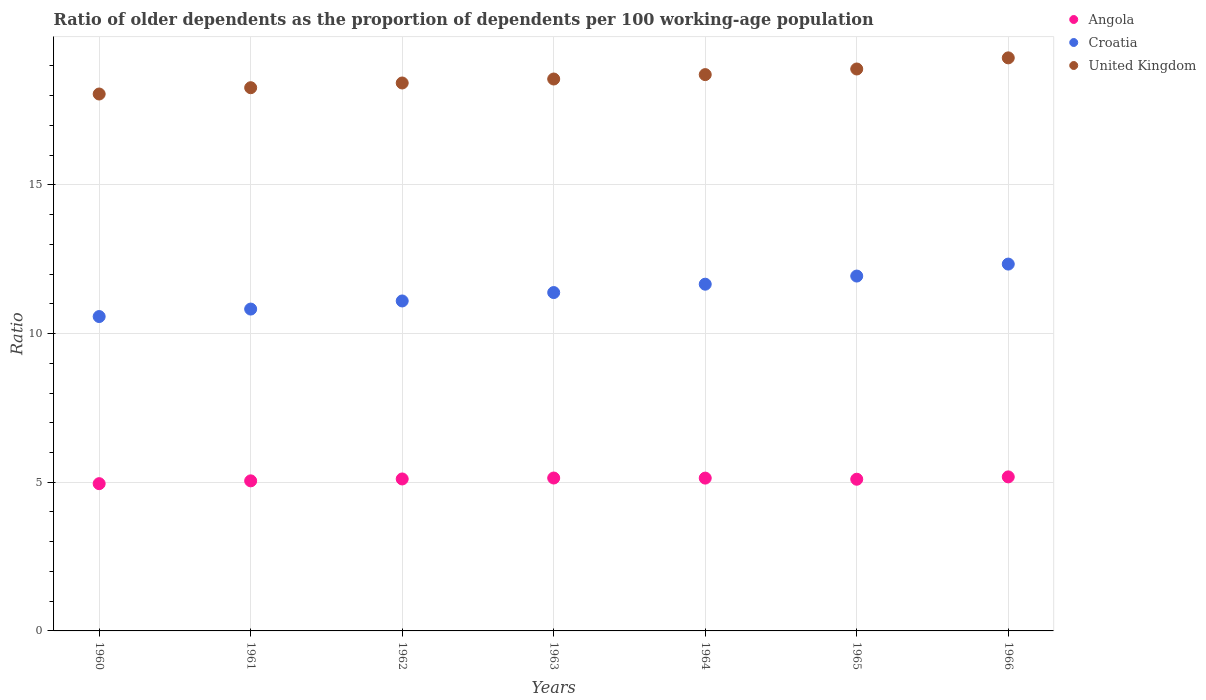How many different coloured dotlines are there?
Your answer should be compact. 3. Is the number of dotlines equal to the number of legend labels?
Provide a succinct answer. Yes. What is the age dependency ratio(old) in Angola in 1961?
Your response must be concise. 5.05. Across all years, what is the maximum age dependency ratio(old) in Angola?
Ensure brevity in your answer.  5.18. Across all years, what is the minimum age dependency ratio(old) in Croatia?
Ensure brevity in your answer.  10.57. In which year was the age dependency ratio(old) in Angola maximum?
Give a very brief answer. 1966. In which year was the age dependency ratio(old) in United Kingdom minimum?
Provide a short and direct response. 1960. What is the total age dependency ratio(old) in United Kingdom in the graph?
Ensure brevity in your answer.  130.18. What is the difference between the age dependency ratio(old) in Angola in 1960 and that in 1962?
Keep it short and to the point. -0.16. What is the difference between the age dependency ratio(old) in Croatia in 1960 and the age dependency ratio(old) in Angola in 1961?
Ensure brevity in your answer.  5.53. What is the average age dependency ratio(old) in Croatia per year?
Offer a very short reply. 11.4. In the year 1960, what is the difference between the age dependency ratio(old) in Croatia and age dependency ratio(old) in United Kingdom?
Ensure brevity in your answer.  -7.48. In how many years, is the age dependency ratio(old) in Croatia greater than 11?
Provide a short and direct response. 5. What is the ratio of the age dependency ratio(old) in United Kingdom in 1961 to that in 1963?
Your answer should be very brief. 0.98. Is the age dependency ratio(old) in Angola in 1961 less than that in 1964?
Your answer should be very brief. Yes. Is the difference between the age dependency ratio(old) in Croatia in 1962 and 1963 greater than the difference between the age dependency ratio(old) in United Kingdom in 1962 and 1963?
Offer a very short reply. No. What is the difference between the highest and the second highest age dependency ratio(old) in United Kingdom?
Keep it short and to the point. 0.37. What is the difference between the highest and the lowest age dependency ratio(old) in United Kingdom?
Make the answer very short. 1.22. In how many years, is the age dependency ratio(old) in United Kingdom greater than the average age dependency ratio(old) in United Kingdom taken over all years?
Keep it short and to the point. 3. Is the sum of the age dependency ratio(old) in Angola in 1960 and 1964 greater than the maximum age dependency ratio(old) in United Kingdom across all years?
Keep it short and to the point. No. Does the age dependency ratio(old) in Angola monotonically increase over the years?
Keep it short and to the point. No. Is the age dependency ratio(old) in Croatia strictly less than the age dependency ratio(old) in United Kingdom over the years?
Keep it short and to the point. Yes. How many dotlines are there?
Provide a short and direct response. 3. How many years are there in the graph?
Provide a succinct answer. 7. Does the graph contain any zero values?
Offer a very short reply. No. Does the graph contain grids?
Offer a very short reply. Yes. Where does the legend appear in the graph?
Your answer should be compact. Top right. What is the title of the graph?
Your answer should be compact. Ratio of older dependents as the proportion of dependents per 100 working-age population. What is the label or title of the X-axis?
Provide a short and direct response. Years. What is the label or title of the Y-axis?
Keep it short and to the point. Ratio. What is the Ratio in Angola in 1960?
Your answer should be compact. 4.95. What is the Ratio of Croatia in 1960?
Your response must be concise. 10.57. What is the Ratio in United Kingdom in 1960?
Your response must be concise. 18.05. What is the Ratio in Angola in 1961?
Your response must be concise. 5.05. What is the Ratio of Croatia in 1961?
Provide a short and direct response. 10.82. What is the Ratio of United Kingdom in 1961?
Offer a very short reply. 18.27. What is the Ratio of Angola in 1962?
Make the answer very short. 5.11. What is the Ratio of Croatia in 1962?
Provide a succinct answer. 11.1. What is the Ratio in United Kingdom in 1962?
Give a very brief answer. 18.43. What is the Ratio in Angola in 1963?
Keep it short and to the point. 5.14. What is the Ratio in Croatia in 1963?
Make the answer very short. 11.38. What is the Ratio of United Kingdom in 1963?
Offer a very short reply. 18.56. What is the Ratio of Angola in 1964?
Make the answer very short. 5.14. What is the Ratio in Croatia in 1964?
Keep it short and to the point. 11.66. What is the Ratio in United Kingdom in 1964?
Ensure brevity in your answer.  18.71. What is the Ratio in Angola in 1965?
Provide a succinct answer. 5.1. What is the Ratio in Croatia in 1965?
Ensure brevity in your answer.  11.93. What is the Ratio of United Kingdom in 1965?
Your answer should be compact. 18.9. What is the Ratio in Angola in 1966?
Your answer should be very brief. 5.18. What is the Ratio of Croatia in 1966?
Offer a terse response. 12.34. What is the Ratio of United Kingdom in 1966?
Offer a terse response. 19.27. Across all years, what is the maximum Ratio of Angola?
Offer a very short reply. 5.18. Across all years, what is the maximum Ratio in Croatia?
Offer a terse response. 12.34. Across all years, what is the maximum Ratio in United Kingdom?
Ensure brevity in your answer.  19.27. Across all years, what is the minimum Ratio of Angola?
Your answer should be compact. 4.95. Across all years, what is the minimum Ratio in Croatia?
Your answer should be compact. 10.57. Across all years, what is the minimum Ratio of United Kingdom?
Your answer should be very brief. 18.05. What is the total Ratio of Angola in the graph?
Give a very brief answer. 35.67. What is the total Ratio of Croatia in the graph?
Keep it short and to the point. 79.8. What is the total Ratio of United Kingdom in the graph?
Your answer should be very brief. 130.18. What is the difference between the Ratio of Angola in 1960 and that in 1961?
Provide a short and direct response. -0.09. What is the difference between the Ratio in Croatia in 1960 and that in 1961?
Offer a terse response. -0.25. What is the difference between the Ratio of United Kingdom in 1960 and that in 1961?
Provide a short and direct response. -0.21. What is the difference between the Ratio of Angola in 1960 and that in 1962?
Ensure brevity in your answer.  -0.16. What is the difference between the Ratio of Croatia in 1960 and that in 1962?
Your answer should be very brief. -0.52. What is the difference between the Ratio in United Kingdom in 1960 and that in 1962?
Give a very brief answer. -0.37. What is the difference between the Ratio in Angola in 1960 and that in 1963?
Your answer should be compact. -0.19. What is the difference between the Ratio of Croatia in 1960 and that in 1963?
Keep it short and to the point. -0.81. What is the difference between the Ratio of United Kingdom in 1960 and that in 1963?
Your answer should be very brief. -0.5. What is the difference between the Ratio of Angola in 1960 and that in 1964?
Offer a terse response. -0.19. What is the difference between the Ratio in Croatia in 1960 and that in 1964?
Provide a succinct answer. -1.09. What is the difference between the Ratio of United Kingdom in 1960 and that in 1964?
Provide a short and direct response. -0.65. What is the difference between the Ratio in Angola in 1960 and that in 1965?
Ensure brevity in your answer.  -0.15. What is the difference between the Ratio of Croatia in 1960 and that in 1965?
Your answer should be compact. -1.36. What is the difference between the Ratio of United Kingdom in 1960 and that in 1965?
Ensure brevity in your answer.  -0.84. What is the difference between the Ratio of Angola in 1960 and that in 1966?
Your response must be concise. -0.23. What is the difference between the Ratio of Croatia in 1960 and that in 1966?
Provide a succinct answer. -1.76. What is the difference between the Ratio in United Kingdom in 1960 and that in 1966?
Your response must be concise. -1.22. What is the difference between the Ratio of Angola in 1961 and that in 1962?
Offer a terse response. -0.06. What is the difference between the Ratio of Croatia in 1961 and that in 1962?
Make the answer very short. -0.27. What is the difference between the Ratio of United Kingdom in 1961 and that in 1962?
Give a very brief answer. -0.16. What is the difference between the Ratio in Angola in 1961 and that in 1963?
Your response must be concise. -0.1. What is the difference between the Ratio of Croatia in 1961 and that in 1963?
Provide a short and direct response. -0.56. What is the difference between the Ratio of United Kingdom in 1961 and that in 1963?
Provide a succinct answer. -0.29. What is the difference between the Ratio in Angola in 1961 and that in 1964?
Make the answer very short. -0.09. What is the difference between the Ratio in Croatia in 1961 and that in 1964?
Your response must be concise. -0.84. What is the difference between the Ratio of United Kingdom in 1961 and that in 1964?
Offer a very short reply. -0.44. What is the difference between the Ratio in Angola in 1961 and that in 1965?
Offer a very short reply. -0.05. What is the difference between the Ratio of Croatia in 1961 and that in 1965?
Offer a terse response. -1.11. What is the difference between the Ratio in United Kingdom in 1961 and that in 1965?
Keep it short and to the point. -0.63. What is the difference between the Ratio in Angola in 1961 and that in 1966?
Provide a succinct answer. -0.13. What is the difference between the Ratio in Croatia in 1961 and that in 1966?
Offer a terse response. -1.51. What is the difference between the Ratio in United Kingdom in 1961 and that in 1966?
Provide a succinct answer. -1. What is the difference between the Ratio of Angola in 1962 and that in 1963?
Provide a succinct answer. -0.03. What is the difference between the Ratio in Croatia in 1962 and that in 1963?
Keep it short and to the point. -0.28. What is the difference between the Ratio of United Kingdom in 1962 and that in 1963?
Offer a very short reply. -0.13. What is the difference between the Ratio in Angola in 1962 and that in 1964?
Offer a very short reply. -0.03. What is the difference between the Ratio in Croatia in 1962 and that in 1964?
Your response must be concise. -0.56. What is the difference between the Ratio of United Kingdom in 1962 and that in 1964?
Your answer should be compact. -0.28. What is the difference between the Ratio of Angola in 1962 and that in 1965?
Keep it short and to the point. 0.01. What is the difference between the Ratio of Croatia in 1962 and that in 1965?
Your answer should be compact. -0.84. What is the difference between the Ratio in United Kingdom in 1962 and that in 1965?
Your answer should be very brief. -0.47. What is the difference between the Ratio of Angola in 1962 and that in 1966?
Offer a very short reply. -0.07. What is the difference between the Ratio of Croatia in 1962 and that in 1966?
Your answer should be very brief. -1.24. What is the difference between the Ratio of United Kingdom in 1962 and that in 1966?
Your response must be concise. -0.84. What is the difference between the Ratio in Angola in 1963 and that in 1964?
Offer a very short reply. 0. What is the difference between the Ratio in Croatia in 1963 and that in 1964?
Give a very brief answer. -0.28. What is the difference between the Ratio in United Kingdom in 1963 and that in 1964?
Give a very brief answer. -0.15. What is the difference between the Ratio in Angola in 1963 and that in 1965?
Offer a very short reply. 0.04. What is the difference between the Ratio of Croatia in 1963 and that in 1965?
Provide a succinct answer. -0.55. What is the difference between the Ratio of United Kingdom in 1963 and that in 1965?
Offer a terse response. -0.34. What is the difference between the Ratio in Angola in 1963 and that in 1966?
Give a very brief answer. -0.04. What is the difference between the Ratio in Croatia in 1963 and that in 1966?
Your answer should be very brief. -0.96. What is the difference between the Ratio in United Kingdom in 1963 and that in 1966?
Make the answer very short. -0.71. What is the difference between the Ratio of Angola in 1964 and that in 1965?
Ensure brevity in your answer.  0.04. What is the difference between the Ratio in Croatia in 1964 and that in 1965?
Ensure brevity in your answer.  -0.27. What is the difference between the Ratio in United Kingdom in 1964 and that in 1965?
Give a very brief answer. -0.19. What is the difference between the Ratio in Angola in 1964 and that in 1966?
Your response must be concise. -0.04. What is the difference between the Ratio in Croatia in 1964 and that in 1966?
Provide a short and direct response. -0.68. What is the difference between the Ratio of United Kingdom in 1964 and that in 1966?
Offer a terse response. -0.56. What is the difference between the Ratio of Angola in 1965 and that in 1966?
Give a very brief answer. -0.08. What is the difference between the Ratio in Croatia in 1965 and that in 1966?
Give a very brief answer. -0.4. What is the difference between the Ratio in United Kingdom in 1965 and that in 1966?
Provide a succinct answer. -0.37. What is the difference between the Ratio in Angola in 1960 and the Ratio in Croatia in 1961?
Provide a short and direct response. -5.87. What is the difference between the Ratio in Angola in 1960 and the Ratio in United Kingdom in 1961?
Give a very brief answer. -13.31. What is the difference between the Ratio in Croatia in 1960 and the Ratio in United Kingdom in 1961?
Make the answer very short. -7.7. What is the difference between the Ratio of Angola in 1960 and the Ratio of Croatia in 1962?
Give a very brief answer. -6.14. What is the difference between the Ratio of Angola in 1960 and the Ratio of United Kingdom in 1962?
Your answer should be very brief. -13.47. What is the difference between the Ratio in Croatia in 1960 and the Ratio in United Kingdom in 1962?
Your answer should be compact. -7.85. What is the difference between the Ratio of Angola in 1960 and the Ratio of Croatia in 1963?
Ensure brevity in your answer.  -6.43. What is the difference between the Ratio in Angola in 1960 and the Ratio in United Kingdom in 1963?
Offer a terse response. -13.61. What is the difference between the Ratio of Croatia in 1960 and the Ratio of United Kingdom in 1963?
Your answer should be compact. -7.99. What is the difference between the Ratio in Angola in 1960 and the Ratio in Croatia in 1964?
Make the answer very short. -6.71. What is the difference between the Ratio in Angola in 1960 and the Ratio in United Kingdom in 1964?
Offer a terse response. -13.76. What is the difference between the Ratio in Croatia in 1960 and the Ratio in United Kingdom in 1964?
Make the answer very short. -8.14. What is the difference between the Ratio in Angola in 1960 and the Ratio in Croatia in 1965?
Your response must be concise. -6.98. What is the difference between the Ratio in Angola in 1960 and the Ratio in United Kingdom in 1965?
Keep it short and to the point. -13.94. What is the difference between the Ratio of Croatia in 1960 and the Ratio of United Kingdom in 1965?
Your answer should be very brief. -8.32. What is the difference between the Ratio in Angola in 1960 and the Ratio in Croatia in 1966?
Provide a short and direct response. -7.38. What is the difference between the Ratio in Angola in 1960 and the Ratio in United Kingdom in 1966?
Your answer should be very brief. -14.32. What is the difference between the Ratio in Croatia in 1960 and the Ratio in United Kingdom in 1966?
Keep it short and to the point. -8.7. What is the difference between the Ratio of Angola in 1961 and the Ratio of Croatia in 1962?
Offer a terse response. -6.05. What is the difference between the Ratio in Angola in 1961 and the Ratio in United Kingdom in 1962?
Provide a succinct answer. -13.38. What is the difference between the Ratio of Croatia in 1961 and the Ratio of United Kingdom in 1962?
Offer a very short reply. -7.6. What is the difference between the Ratio in Angola in 1961 and the Ratio in Croatia in 1963?
Ensure brevity in your answer.  -6.33. What is the difference between the Ratio in Angola in 1961 and the Ratio in United Kingdom in 1963?
Keep it short and to the point. -13.51. What is the difference between the Ratio in Croatia in 1961 and the Ratio in United Kingdom in 1963?
Give a very brief answer. -7.74. What is the difference between the Ratio of Angola in 1961 and the Ratio of Croatia in 1964?
Keep it short and to the point. -6.61. What is the difference between the Ratio in Angola in 1961 and the Ratio in United Kingdom in 1964?
Your answer should be very brief. -13.66. What is the difference between the Ratio of Croatia in 1961 and the Ratio of United Kingdom in 1964?
Your response must be concise. -7.88. What is the difference between the Ratio of Angola in 1961 and the Ratio of Croatia in 1965?
Provide a short and direct response. -6.89. What is the difference between the Ratio in Angola in 1961 and the Ratio in United Kingdom in 1965?
Your answer should be compact. -13.85. What is the difference between the Ratio of Croatia in 1961 and the Ratio of United Kingdom in 1965?
Make the answer very short. -8.07. What is the difference between the Ratio of Angola in 1961 and the Ratio of Croatia in 1966?
Your answer should be compact. -7.29. What is the difference between the Ratio of Angola in 1961 and the Ratio of United Kingdom in 1966?
Make the answer very short. -14.22. What is the difference between the Ratio in Croatia in 1961 and the Ratio in United Kingdom in 1966?
Offer a terse response. -8.45. What is the difference between the Ratio of Angola in 1962 and the Ratio of Croatia in 1963?
Your answer should be compact. -6.27. What is the difference between the Ratio in Angola in 1962 and the Ratio in United Kingdom in 1963?
Provide a short and direct response. -13.45. What is the difference between the Ratio of Croatia in 1962 and the Ratio of United Kingdom in 1963?
Your response must be concise. -7.46. What is the difference between the Ratio in Angola in 1962 and the Ratio in Croatia in 1964?
Ensure brevity in your answer.  -6.55. What is the difference between the Ratio of Angola in 1962 and the Ratio of United Kingdom in 1964?
Give a very brief answer. -13.6. What is the difference between the Ratio in Croatia in 1962 and the Ratio in United Kingdom in 1964?
Keep it short and to the point. -7.61. What is the difference between the Ratio in Angola in 1962 and the Ratio in Croatia in 1965?
Offer a very short reply. -6.82. What is the difference between the Ratio in Angola in 1962 and the Ratio in United Kingdom in 1965?
Make the answer very short. -13.79. What is the difference between the Ratio of Croatia in 1962 and the Ratio of United Kingdom in 1965?
Your answer should be very brief. -7.8. What is the difference between the Ratio in Angola in 1962 and the Ratio in Croatia in 1966?
Provide a short and direct response. -7.23. What is the difference between the Ratio of Angola in 1962 and the Ratio of United Kingdom in 1966?
Keep it short and to the point. -14.16. What is the difference between the Ratio in Croatia in 1962 and the Ratio in United Kingdom in 1966?
Ensure brevity in your answer.  -8.17. What is the difference between the Ratio in Angola in 1963 and the Ratio in Croatia in 1964?
Provide a succinct answer. -6.52. What is the difference between the Ratio in Angola in 1963 and the Ratio in United Kingdom in 1964?
Your answer should be compact. -13.57. What is the difference between the Ratio of Croatia in 1963 and the Ratio of United Kingdom in 1964?
Your answer should be very brief. -7.33. What is the difference between the Ratio in Angola in 1963 and the Ratio in Croatia in 1965?
Offer a terse response. -6.79. What is the difference between the Ratio of Angola in 1963 and the Ratio of United Kingdom in 1965?
Offer a terse response. -13.75. What is the difference between the Ratio in Croatia in 1963 and the Ratio in United Kingdom in 1965?
Provide a short and direct response. -7.52. What is the difference between the Ratio of Angola in 1963 and the Ratio of Croatia in 1966?
Ensure brevity in your answer.  -7.19. What is the difference between the Ratio of Angola in 1963 and the Ratio of United Kingdom in 1966?
Give a very brief answer. -14.13. What is the difference between the Ratio in Croatia in 1963 and the Ratio in United Kingdom in 1966?
Your answer should be very brief. -7.89. What is the difference between the Ratio in Angola in 1964 and the Ratio in Croatia in 1965?
Provide a succinct answer. -6.79. What is the difference between the Ratio of Angola in 1964 and the Ratio of United Kingdom in 1965?
Your answer should be compact. -13.76. What is the difference between the Ratio in Croatia in 1964 and the Ratio in United Kingdom in 1965?
Your answer should be very brief. -7.24. What is the difference between the Ratio of Angola in 1964 and the Ratio of Croatia in 1966?
Provide a short and direct response. -7.2. What is the difference between the Ratio in Angola in 1964 and the Ratio in United Kingdom in 1966?
Your response must be concise. -14.13. What is the difference between the Ratio in Croatia in 1964 and the Ratio in United Kingdom in 1966?
Provide a succinct answer. -7.61. What is the difference between the Ratio in Angola in 1965 and the Ratio in Croatia in 1966?
Ensure brevity in your answer.  -7.23. What is the difference between the Ratio of Angola in 1965 and the Ratio of United Kingdom in 1966?
Your answer should be very brief. -14.17. What is the difference between the Ratio in Croatia in 1965 and the Ratio in United Kingdom in 1966?
Provide a short and direct response. -7.34. What is the average Ratio of Angola per year?
Offer a very short reply. 5.1. What is the average Ratio in Croatia per year?
Your answer should be very brief. 11.4. What is the average Ratio of United Kingdom per year?
Offer a terse response. 18.6. In the year 1960, what is the difference between the Ratio of Angola and Ratio of Croatia?
Give a very brief answer. -5.62. In the year 1960, what is the difference between the Ratio of Angola and Ratio of United Kingdom?
Your response must be concise. -13.1. In the year 1960, what is the difference between the Ratio in Croatia and Ratio in United Kingdom?
Make the answer very short. -7.48. In the year 1961, what is the difference between the Ratio of Angola and Ratio of Croatia?
Provide a succinct answer. -5.78. In the year 1961, what is the difference between the Ratio in Angola and Ratio in United Kingdom?
Ensure brevity in your answer.  -13.22. In the year 1961, what is the difference between the Ratio in Croatia and Ratio in United Kingdom?
Keep it short and to the point. -7.44. In the year 1962, what is the difference between the Ratio of Angola and Ratio of Croatia?
Keep it short and to the point. -5.99. In the year 1962, what is the difference between the Ratio of Angola and Ratio of United Kingdom?
Offer a very short reply. -13.32. In the year 1962, what is the difference between the Ratio in Croatia and Ratio in United Kingdom?
Provide a succinct answer. -7.33. In the year 1963, what is the difference between the Ratio in Angola and Ratio in Croatia?
Your response must be concise. -6.24. In the year 1963, what is the difference between the Ratio in Angola and Ratio in United Kingdom?
Offer a very short reply. -13.42. In the year 1963, what is the difference between the Ratio of Croatia and Ratio of United Kingdom?
Provide a short and direct response. -7.18. In the year 1964, what is the difference between the Ratio in Angola and Ratio in Croatia?
Give a very brief answer. -6.52. In the year 1964, what is the difference between the Ratio of Angola and Ratio of United Kingdom?
Give a very brief answer. -13.57. In the year 1964, what is the difference between the Ratio of Croatia and Ratio of United Kingdom?
Your answer should be compact. -7.05. In the year 1965, what is the difference between the Ratio of Angola and Ratio of Croatia?
Offer a very short reply. -6.83. In the year 1965, what is the difference between the Ratio of Angola and Ratio of United Kingdom?
Give a very brief answer. -13.8. In the year 1965, what is the difference between the Ratio in Croatia and Ratio in United Kingdom?
Your answer should be compact. -6.96. In the year 1966, what is the difference between the Ratio of Angola and Ratio of Croatia?
Your answer should be very brief. -7.16. In the year 1966, what is the difference between the Ratio of Angola and Ratio of United Kingdom?
Provide a succinct answer. -14.09. In the year 1966, what is the difference between the Ratio in Croatia and Ratio in United Kingdom?
Your answer should be compact. -6.93. What is the ratio of the Ratio of Angola in 1960 to that in 1961?
Offer a very short reply. 0.98. What is the ratio of the Ratio of Croatia in 1960 to that in 1961?
Give a very brief answer. 0.98. What is the ratio of the Ratio of United Kingdom in 1960 to that in 1961?
Make the answer very short. 0.99. What is the ratio of the Ratio of Angola in 1960 to that in 1962?
Give a very brief answer. 0.97. What is the ratio of the Ratio in Croatia in 1960 to that in 1962?
Give a very brief answer. 0.95. What is the ratio of the Ratio in United Kingdom in 1960 to that in 1962?
Your answer should be very brief. 0.98. What is the ratio of the Ratio in Angola in 1960 to that in 1963?
Make the answer very short. 0.96. What is the ratio of the Ratio in Croatia in 1960 to that in 1963?
Your answer should be compact. 0.93. What is the ratio of the Ratio in United Kingdom in 1960 to that in 1963?
Keep it short and to the point. 0.97. What is the ratio of the Ratio in Angola in 1960 to that in 1964?
Offer a very short reply. 0.96. What is the ratio of the Ratio in Croatia in 1960 to that in 1964?
Give a very brief answer. 0.91. What is the ratio of the Ratio of United Kingdom in 1960 to that in 1964?
Your response must be concise. 0.97. What is the ratio of the Ratio of Angola in 1960 to that in 1965?
Offer a terse response. 0.97. What is the ratio of the Ratio in Croatia in 1960 to that in 1965?
Provide a succinct answer. 0.89. What is the ratio of the Ratio of United Kingdom in 1960 to that in 1965?
Offer a very short reply. 0.96. What is the ratio of the Ratio of Angola in 1960 to that in 1966?
Offer a very short reply. 0.96. What is the ratio of the Ratio of Croatia in 1960 to that in 1966?
Make the answer very short. 0.86. What is the ratio of the Ratio in United Kingdom in 1960 to that in 1966?
Give a very brief answer. 0.94. What is the ratio of the Ratio in Angola in 1961 to that in 1962?
Give a very brief answer. 0.99. What is the ratio of the Ratio of Croatia in 1961 to that in 1962?
Offer a terse response. 0.98. What is the ratio of the Ratio in United Kingdom in 1961 to that in 1962?
Give a very brief answer. 0.99. What is the ratio of the Ratio in Angola in 1961 to that in 1963?
Give a very brief answer. 0.98. What is the ratio of the Ratio of Croatia in 1961 to that in 1963?
Keep it short and to the point. 0.95. What is the ratio of the Ratio in United Kingdom in 1961 to that in 1963?
Keep it short and to the point. 0.98. What is the ratio of the Ratio of Angola in 1961 to that in 1964?
Your answer should be very brief. 0.98. What is the ratio of the Ratio of Croatia in 1961 to that in 1964?
Your response must be concise. 0.93. What is the ratio of the Ratio of United Kingdom in 1961 to that in 1964?
Provide a short and direct response. 0.98. What is the ratio of the Ratio in Angola in 1961 to that in 1965?
Give a very brief answer. 0.99. What is the ratio of the Ratio in Croatia in 1961 to that in 1965?
Your answer should be very brief. 0.91. What is the ratio of the Ratio in United Kingdom in 1961 to that in 1965?
Offer a terse response. 0.97. What is the ratio of the Ratio of Angola in 1961 to that in 1966?
Offer a very short reply. 0.97. What is the ratio of the Ratio of Croatia in 1961 to that in 1966?
Offer a terse response. 0.88. What is the ratio of the Ratio of United Kingdom in 1961 to that in 1966?
Provide a short and direct response. 0.95. What is the ratio of the Ratio in Angola in 1962 to that in 1963?
Give a very brief answer. 0.99. What is the ratio of the Ratio in Croatia in 1962 to that in 1963?
Offer a very short reply. 0.98. What is the ratio of the Ratio of Croatia in 1962 to that in 1964?
Make the answer very short. 0.95. What is the ratio of the Ratio of United Kingdom in 1962 to that in 1964?
Make the answer very short. 0.98. What is the ratio of the Ratio in Angola in 1962 to that in 1965?
Offer a terse response. 1. What is the ratio of the Ratio in Croatia in 1962 to that in 1965?
Provide a succinct answer. 0.93. What is the ratio of the Ratio of United Kingdom in 1962 to that in 1965?
Ensure brevity in your answer.  0.98. What is the ratio of the Ratio of Angola in 1962 to that in 1966?
Provide a succinct answer. 0.99. What is the ratio of the Ratio in Croatia in 1962 to that in 1966?
Offer a terse response. 0.9. What is the ratio of the Ratio in United Kingdom in 1962 to that in 1966?
Your response must be concise. 0.96. What is the ratio of the Ratio of Croatia in 1963 to that in 1964?
Give a very brief answer. 0.98. What is the ratio of the Ratio of Croatia in 1963 to that in 1965?
Provide a succinct answer. 0.95. What is the ratio of the Ratio of United Kingdom in 1963 to that in 1965?
Keep it short and to the point. 0.98. What is the ratio of the Ratio in Croatia in 1963 to that in 1966?
Your answer should be compact. 0.92. What is the ratio of the Ratio in United Kingdom in 1963 to that in 1966?
Your answer should be very brief. 0.96. What is the ratio of the Ratio of Angola in 1964 to that in 1965?
Ensure brevity in your answer.  1.01. What is the ratio of the Ratio in Croatia in 1964 to that in 1965?
Make the answer very short. 0.98. What is the ratio of the Ratio in United Kingdom in 1964 to that in 1965?
Provide a short and direct response. 0.99. What is the ratio of the Ratio of Angola in 1964 to that in 1966?
Provide a succinct answer. 0.99. What is the ratio of the Ratio of Croatia in 1964 to that in 1966?
Provide a short and direct response. 0.95. What is the ratio of the Ratio of United Kingdom in 1964 to that in 1966?
Your response must be concise. 0.97. What is the ratio of the Ratio in Angola in 1965 to that in 1966?
Offer a very short reply. 0.98. What is the ratio of the Ratio of Croatia in 1965 to that in 1966?
Ensure brevity in your answer.  0.97. What is the ratio of the Ratio in United Kingdom in 1965 to that in 1966?
Your response must be concise. 0.98. What is the difference between the highest and the second highest Ratio in Angola?
Your answer should be compact. 0.04. What is the difference between the highest and the second highest Ratio in Croatia?
Provide a succinct answer. 0.4. What is the difference between the highest and the second highest Ratio in United Kingdom?
Provide a succinct answer. 0.37. What is the difference between the highest and the lowest Ratio of Angola?
Your answer should be compact. 0.23. What is the difference between the highest and the lowest Ratio of Croatia?
Your answer should be compact. 1.76. What is the difference between the highest and the lowest Ratio in United Kingdom?
Make the answer very short. 1.22. 